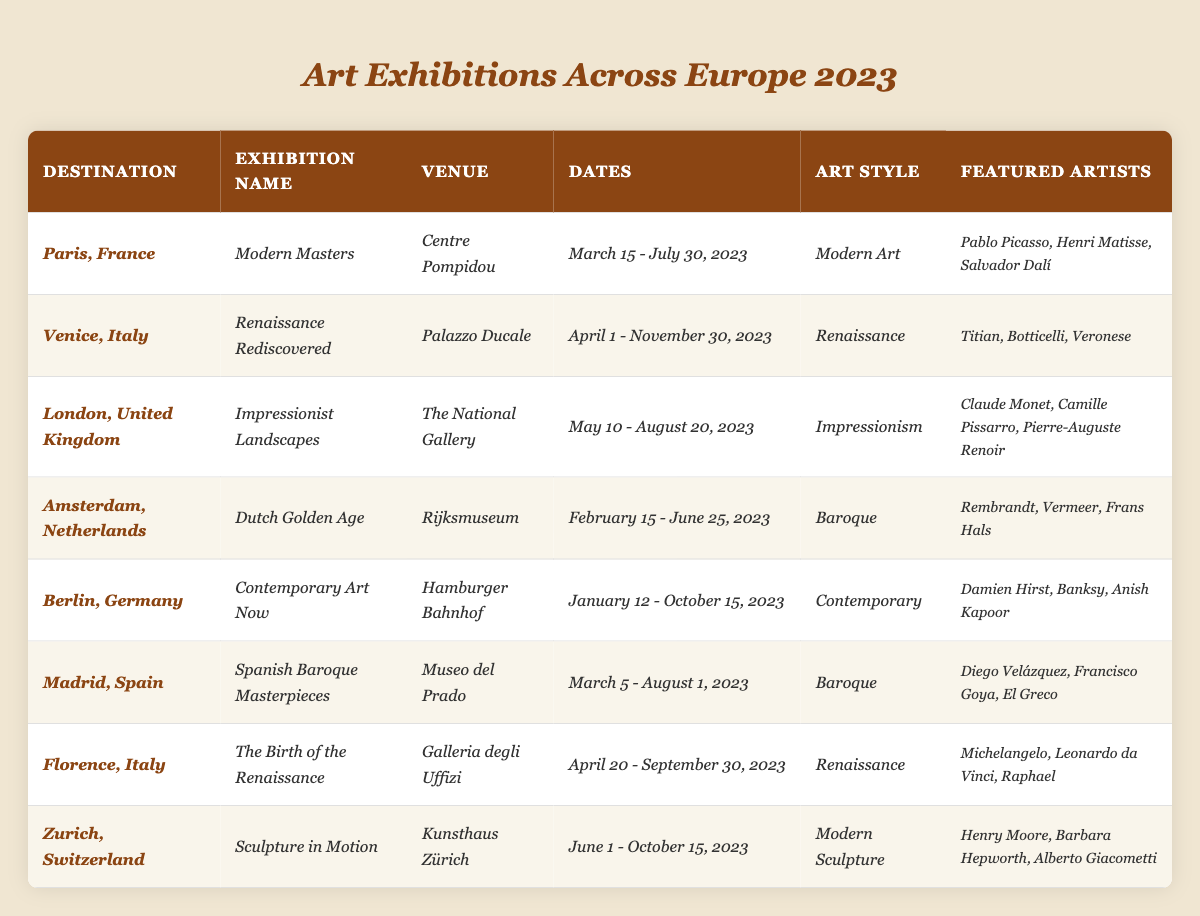What exhibition is happening in Berlin, Germany? The table lists the exhibition names along with their respective destinations. The exhibition in Berlin, Germany, is "Contemporary Art Now."
Answer: Contemporary Art Now Which artists are featured in the exhibition "Modern Masters"? By looking at the row for "Modern Masters" under the exhibition name in Paris, France, the featured artists are listed as Pablo Picasso, Henri Matisse, and Salvador Dalí.
Answer: Pablo Picasso, Henri Matisse, Salvador Dalí What is the art style of the exhibition that takes place in Amsterdam? The table's row for Amsterdam shows that the exhibition "Dutch Golden Age" has the art style categorized as Baroque.
Answer: Baroque How many exhibitions feature the Renaissance art style? The table mentions that there are exhibitions in Venice ("Renaissance Rediscovered") and in Florence ("The Birth of the Renaissance") that are categorized under the Renaissance art style. Therefore, there are two exhibitions.
Answer: 2 Which destination has an exhibition focused on Impressionism? The row for London indicates that the exhibition titled "Impressionist Landscapes" falls under the category of Impressionism.
Answer: London, United Kingdom Is there an exhibition featuring artists from the Dutch Golden Age? According to the table, the exhibition "Dutch Golden Age" features artists Rembrandt, Vermeer, and Frans Hals, which confirms there is an exhibition focused on this art style.
Answer: Yes What are the exhibition dates for "Spanish Baroque Masterpieces"? The table specifies that the exhibition "Spanish Baroque Masterpieces" in Madrid runs from March 5 to August 1, 2023.
Answer: March 5 - August 1, 2023 Which exhibition has the longest duration from start to end? By examining the date ranges, we find that "Renaissance Rediscovered" in Venice lasts from April 1 to November 30, 2023, a total of approximately 8 months, which is the longest among the listed exhibitions.
Answer: Renaissance Rediscovered Count how many exhibitions end in October 2023. From the table, we can see two exhibitions that end in October: "Contemporary Art Now" in Berlin (October 15) and "Sculpture in Motion" in Zurich (October 15). Therefore, the total is two exhibitions.
Answer: 2 What venue hosts the exhibition "Sculpture in Motion"? By referring to the row for the exhibition "Sculpture in Motion," it is listed that the venue is Kunsthaus Zürich.
Answer: Kunsthaus Zürich Are all the featured artists in the exhibition "Impressionist Landscapes" from the same country? The featured artists for "Impressionist Landscapes" are Claude Monet, Camille Pissarro, and Pierre-Auguste Renoir, all of whom are French; thus, they are from the same country.
Answer: Yes 